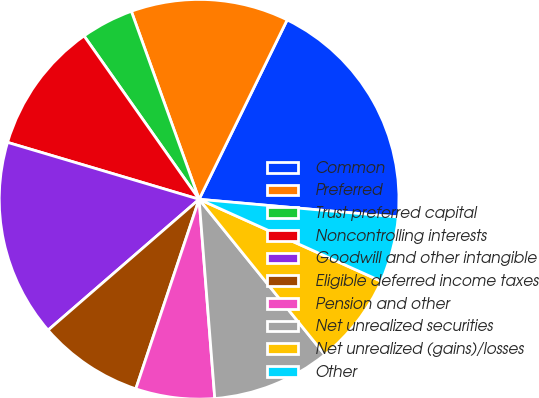Convert chart. <chart><loc_0><loc_0><loc_500><loc_500><pie_chart><fcel>Common<fcel>Preferred<fcel>Trust preferred capital<fcel>Noncontrolling interests<fcel>Goodwill and other intangible<fcel>Eligible deferred income taxes<fcel>Pension and other<fcel>Net unrealized securities<fcel>Net unrealized (gains)/losses<fcel>Other<nl><fcel>19.15%<fcel>12.77%<fcel>4.26%<fcel>10.64%<fcel>15.96%<fcel>8.51%<fcel>6.38%<fcel>9.57%<fcel>7.45%<fcel>5.32%<nl></chart> 